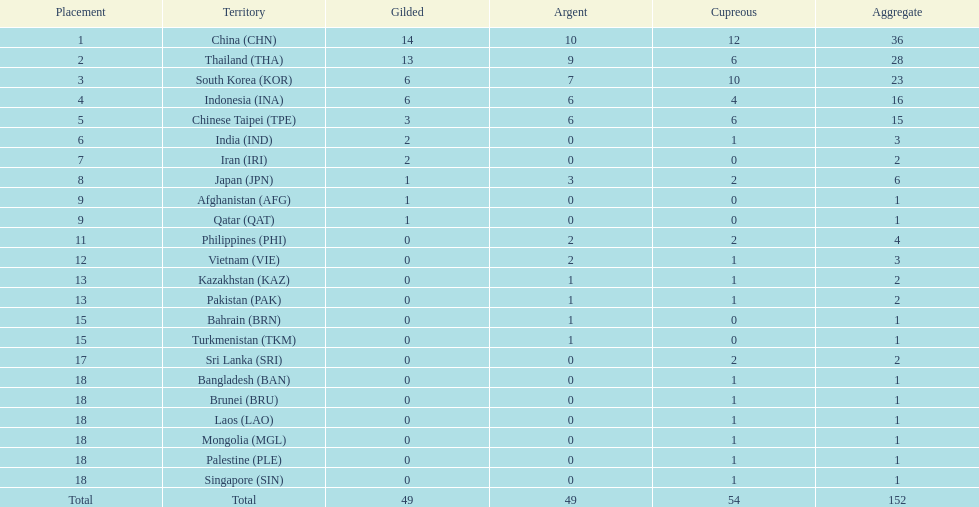I'm looking to parse the entire table for insights. Could you assist me with that? {'header': ['Placement', 'Territory', 'Gilded', 'Argent', 'Cupreous', 'Aggregate'], 'rows': [['1', 'China\xa0(CHN)', '14', '10', '12', '36'], ['2', 'Thailand\xa0(THA)', '13', '9', '6', '28'], ['3', 'South Korea\xa0(KOR)', '6', '7', '10', '23'], ['4', 'Indonesia\xa0(INA)', '6', '6', '4', '16'], ['5', 'Chinese Taipei\xa0(TPE)', '3', '6', '6', '15'], ['6', 'India\xa0(IND)', '2', '0', '1', '3'], ['7', 'Iran\xa0(IRI)', '2', '0', '0', '2'], ['8', 'Japan\xa0(JPN)', '1', '3', '2', '6'], ['9', 'Afghanistan\xa0(AFG)', '1', '0', '0', '1'], ['9', 'Qatar\xa0(QAT)', '1', '0', '0', '1'], ['11', 'Philippines\xa0(PHI)', '0', '2', '2', '4'], ['12', 'Vietnam\xa0(VIE)', '0', '2', '1', '3'], ['13', 'Kazakhstan\xa0(KAZ)', '0', '1', '1', '2'], ['13', 'Pakistan\xa0(PAK)', '0', '1', '1', '2'], ['15', 'Bahrain\xa0(BRN)', '0', '1', '0', '1'], ['15', 'Turkmenistan\xa0(TKM)', '0', '1', '0', '1'], ['17', 'Sri Lanka\xa0(SRI)', '0', '0', '2', '2'], ['18', 'Bangladesh\xa0(BAN)', '0', '0', '1', '1'], ['18', 'Brunei\xa0(BRU)', '0', '0', '1', '1'], ['18', 'Laos\xa0(LAO)', '0', '0', '1', '1'], ['18', 'Mongolia\xa0(MGL)', '0', '0', '1', '1'], ['18', 'Palestine\xa0(PLE)', '0', '0', '1', '1'], ['18', 'Singapore\xa0(SIN)', '0', '0', '1', '1'], ['Total', 'Total', '49', '49', '54', '152']]} What is the total number of nations that participated in the beach games of 2012? 23. 